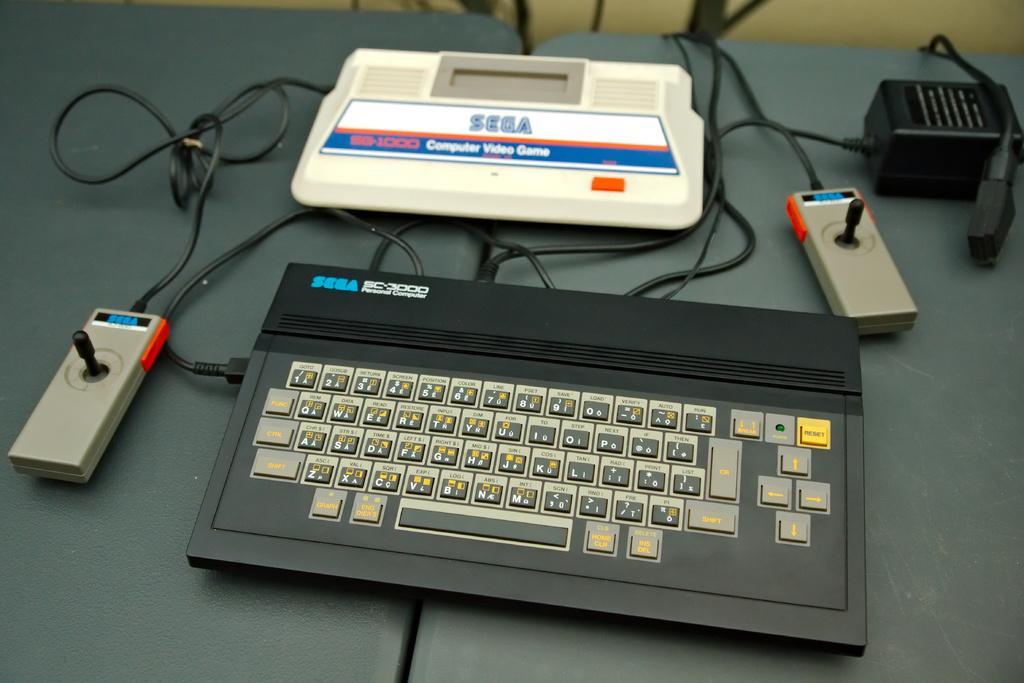In one or two sentences, can you explain what this image depicts? In the center of the image we can see a platform. On the platform, we can see one keyboard, wires and some objects. In the background there is a wall. 